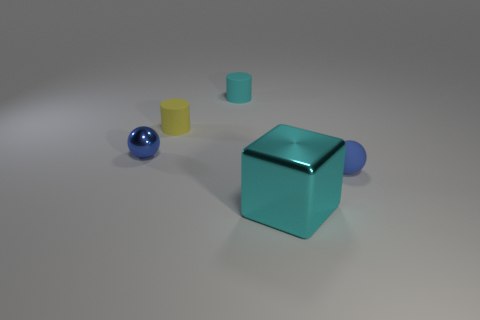Add 5 big yellow things. How many objects exist? 10 Subtract all cubes. How many objects are left? 4 Subtract all small blue metallic spheres. Subtract all rubber objects. How many objects are left? 1 Add 5 large cyan cubes. How many large cyan cubes are left? 6 Add 1 blue shiny balls. How many blue shiny balls exist? 2 Subtract 0 brown cylinders. How many objects are left? 5 